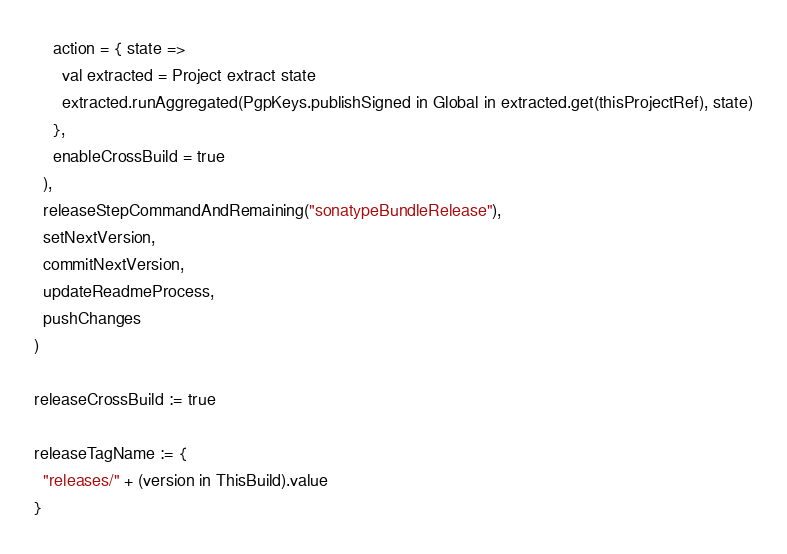<code> <loc_0><loc_0><loc_500><loc_500><_Scala_>    action = { state =>
      val extracted = Project extract state
      extracted.runAggregated(PgpKeys.publishSigned in Global in extracted.get(thisProjectRef), state)
    },
    enableCrossBuild = true
  ),
  releaseStepCommandAndRemaining("sonatypeBundleRelease"),
  setNextVersion,
  commitNextVersion,
  updateReadmeProcess,
  pushChanges
)

releaseCrossBuild := true

releaseTagName := {
  "releases/" + (version in ThisBuild).value
}
</code> 